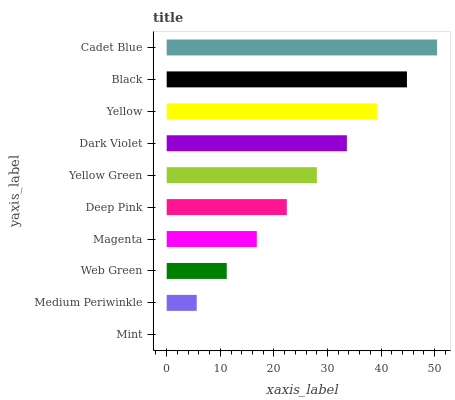Is Mint the minimum?
Answer yes or no. Yes. Is Cadet Blue the maximum?
Answer yes or no. Yes. Is Medium Periwinkle the minimum?
Answer yes or no. No. Is Medium Periwinkle the maximum?
Answer yes or no. No. Is Medium Periwinkle greater than Mint?
Answer yes or no. Yes. Is Mint less than Medium Periwinkle?
Answer yes or no. Yes. Is Mint greater than Medium Periwinkle?
Answer yes or no. No. Is Medium Periwinkle less than Mint?
Answer yes or no. No. Is Yellow Green the high median?
Answer yes or no. Yes. Is Deep Pink the low median?
Answer yes or no. Yes. Is Deep Pink the high median?
Answer yes or no. No. Is Cadet Blue the low median?
Answer yes or no. No. 